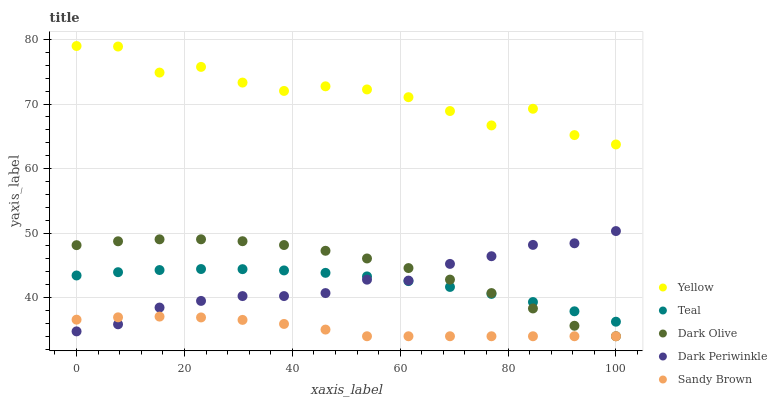Does Sandy Brown have the minimum area under the curve?
Answer yes or no. Yes. Does Yellow have the maximum area under the curve?
Answer yes or no. Yes. Does Teal have the minimum area under the curve?
Answer yes or no. No. Does Teal have the maximum area under the curve?
Answer yes or no. No. Is Teal the smoothest?
Answer yes or no. Yes. Is Yellow the roughest?
Answer yes or no. Yes. Is Sandy Brown the smoothest?
Answer yes or no. No. Is Sandy Brown the roughest?
Answer yes or no. No. Does Dark Olive have the lowest value?
Answer yes or no. Yes. Does Teal have the lowest value?
Answer yes or no. No. Does Yellow have the highest value?
Answer yes or no. Yes. Does Teal have the highest value?
Answer yes or no. No. Is Dark Periwinkle less than Yellow?
Answer yes or no. Yes. Is Yellow greater than Dark Periwinkle?
Answer yes or no. Yes. Does Dark Olive intersect Dark Periwinkle?
Answer yes or no. Yes. Is Dark Olive less than Dark Periwinkle?
Answer yes or no. No. Is Dark Olive greater than Dark Periwinkle?
Answer yes or no. No. Does Dark Periwinkle intersect Yellow?
Answer yes or no. No. 